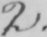Transcribe the text shown in this historical manuscript line. 2 . 